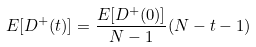Convert formula to latex. <formula><loc_0><loc_0><loc_500><loc_500>E [ D ^ { + } ( t ) ] = \frac { E [ D ^ { + } ( 0 ) ] } { N - 1 } ( N - t - 1 )</formula> 